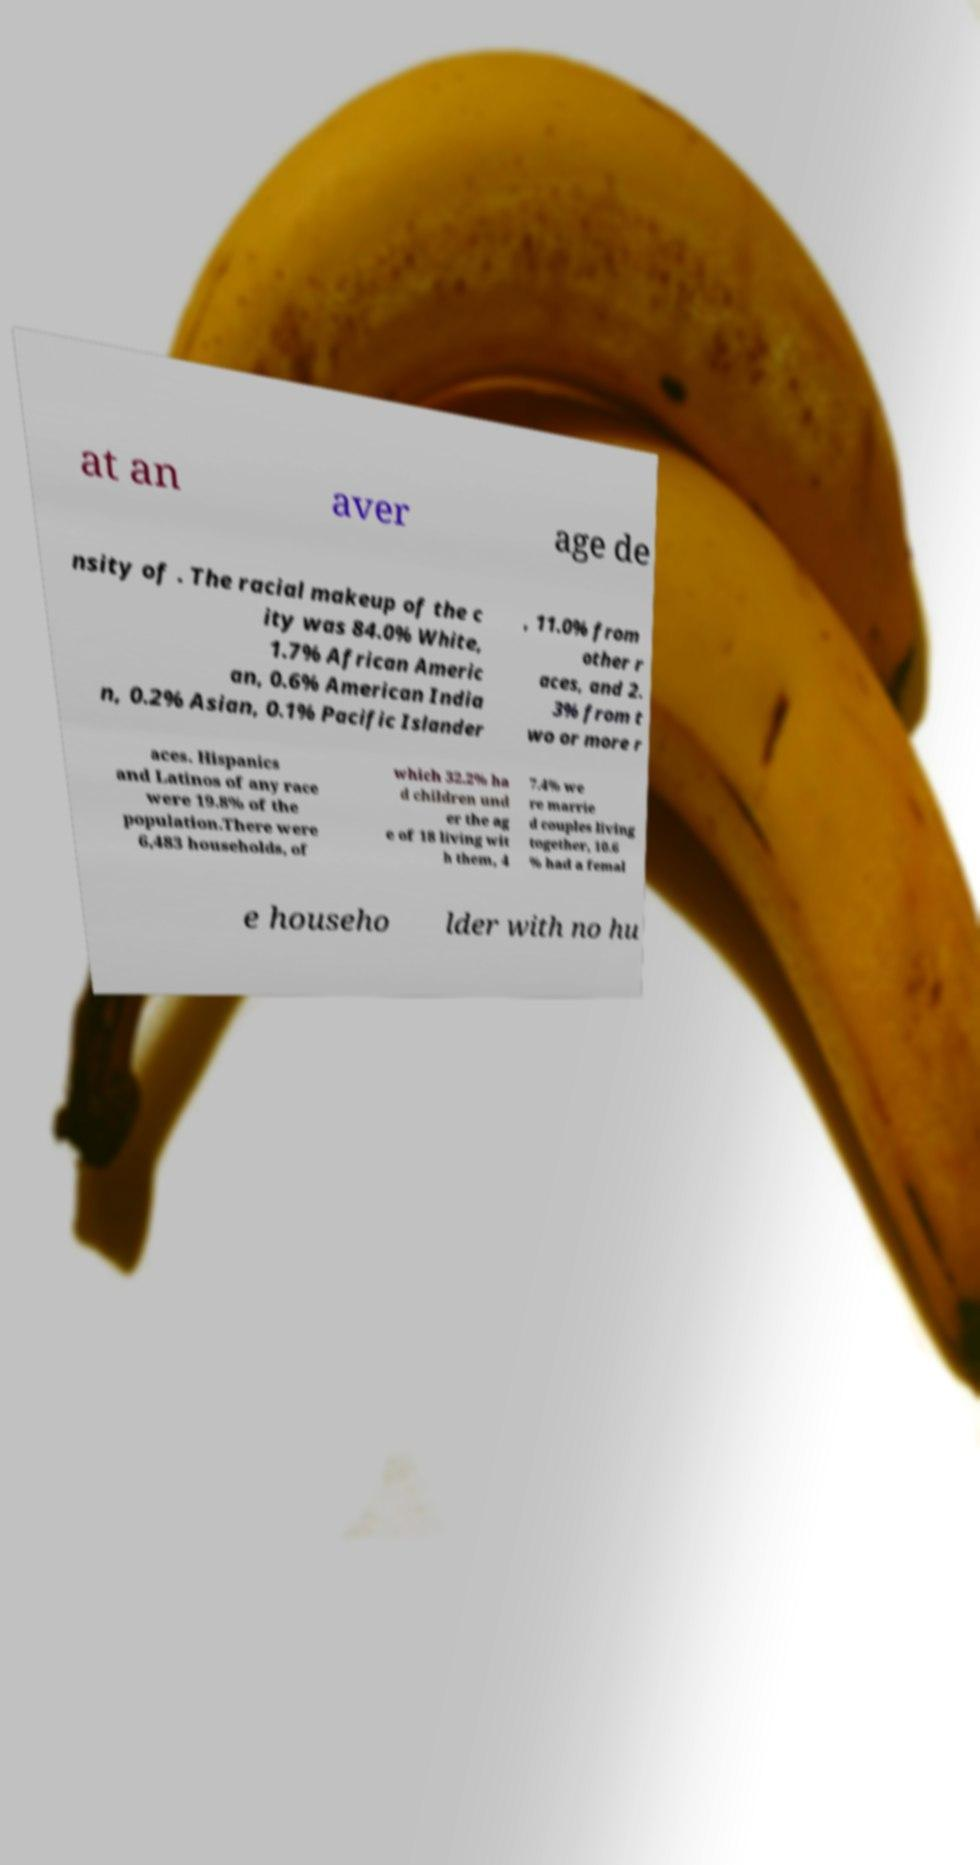Please read and relay the text visible in this image. What does it say? at an aver age de nsity of . The racial makeup of the c ity was 84.0% White, 1.7% African Americ an, 0.6% American India n, 0.2% Asian, 0.1% Pacific Islander , 11.0% from other r aces, and 2. 3% from t wo or more r aces. Hispanics and Latinos of any race were 19.8% of the population.There were 6,483 households, of which 32.2% ha d children und er the ag e of 18 living wit h them, 4 7.4% we re marrie d couples living together, 10.6 % had a femal e househo lder with no hu 